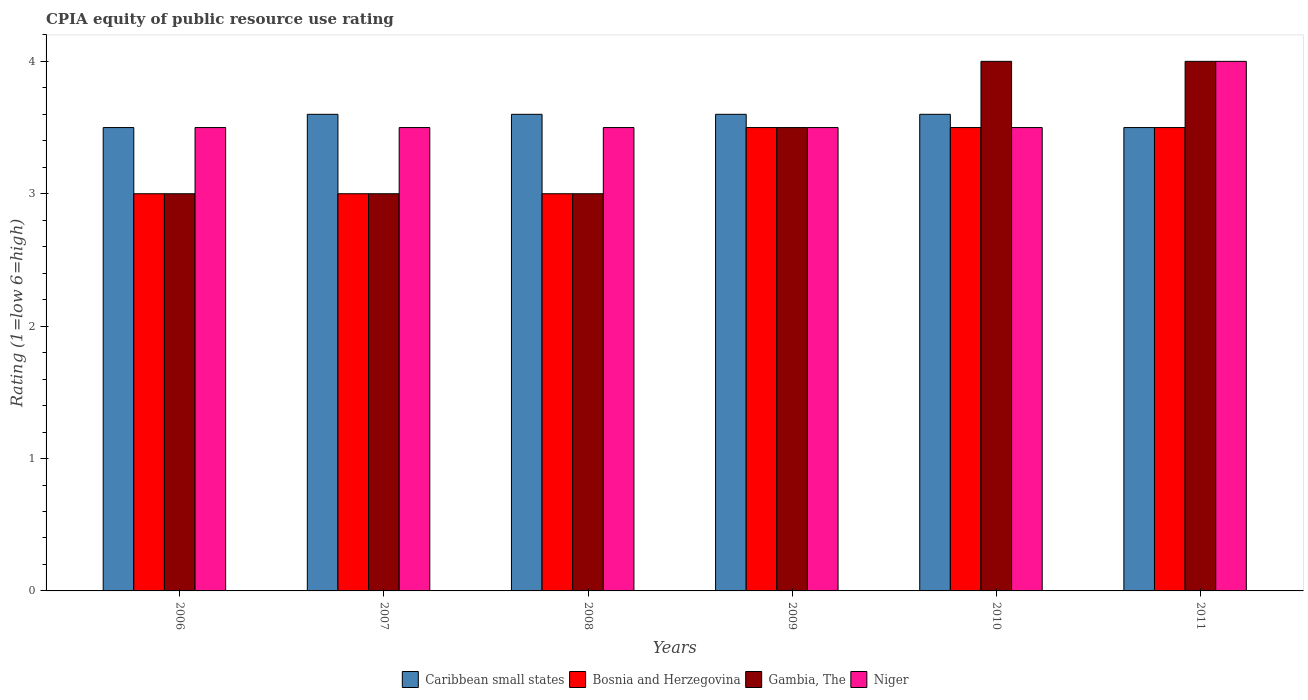How many groups of bars are there?
Provide a short and direct response. 6. How many bars are there on the 4th tick from the left?
Make the answer very short. 4. What is the label of the 3rd group of bars from the left?
Your response must be concise. 2008. In how many cases, is the number of bars for a given year not equal to the number of legend labels?
Give a very brief answer. 0. What is the CPIA rating in Gambia, The in 2009?
Offer a terse response. 3.5. In which year was the CPIA rating in Niger minimum?
Make the answer very short. 2006. What is the average CPIA rating in Bosnia and Herzegovina per year?
Keep it short and to the point. 3.25. In the year 2010, what is the difference between the CPIA rating in Niger and CPIA rating in Caribbean small states?
Offer a terse response. -0.1. What is the ratio of the CPIA rating in Caribbean small states in 2007 to that in 2011?
Keep it short and to the point. 1.03. What is the difference between the highest and the lowest CPIA rating in Gambia, The?
Make the answer very short. 1. Is the sum of the CPIA rating in Niger in 2009 and 2011 greater than the maximum CPIA rating in Bosnia and Herzegovina across all years?
Your response must be concise. Yes. Is it the case that in every year, the sum of the CPIA rating in Bosnia and Herzegovina and CPIA rating in Niger is greater than the sum of CPIA rating in Gambia, The and CPIA rating in Caribbean small states?
Your answer should be compact. No. What does the 4th bar from the left in 2006 represents?
Provide a succinct answer. Niger. What does the 4th bar from the right in 2011 represents?
Provide a short and direct response. Caribbean small states. How many bars are there?
Provide a succinct answer. 24. Are all the bars in the graph horizontal?
Your answer should be very brief. No. What is the difference between two consecutive major ticks on the Y-axis?
Provide a short and direct response. 1. Does the graph contain any zero values?
Give a very brief answer. No. Does the graph contain grids?
Provide a short and direct response. No. How many legend labels are there?
Your answer should be very brief. 4. How are the legend labels stacked?
Ensure brevity in your answer.  Horizontal. What is the title of the graph?
Your answer should be very brief. CPIA equity of public resource use rating. What is the label or title of the X-axis?
Provide a short and direct response. Years. What is the Rating (1=low 6=high) in Gambia, The in 2007?
Offer a very short reply. 3. What is the Rating (1=low 6=high) of Niger in 2007?
Offer a very short reply. 3.5. What is the Rating (1=low 6=high) in Gambia, The in 2008?
Give a very brief answer. 3. What is the Rating (1=low 6=high) of Niger in 2008?
Your response must be concise. 3.5. What is the Rating (1=low 6=high) of Gambia, The in 2009?
Your response must be concise. 3.5. What is the Rating (1=low 6=high) of Niger in 2009?
Your answer should be compact. 3.5. What is the Rating (1=low 6=high) of Caribbean small states in 2010?
Provide a short and direct response. 3.6. What is the Rating (1=low 6=high) in Gambia, The in 2011?
Give a very brief answer. 4. Across all years, what is the maximum Rating (1=low 6=high) of Bosnia and Herzegovina?
Offer a very short reply. 3.5. Across all years, what is the minimum Rating (1=low 6=high) in Caribbean small states?
Your answer should be very brief. 3.5. Across all years, what is the minimum Rating (1=low 6=high) in Gambia, The?
Your answer should be compact. 3. What is the total Rating (1=low 6=high) in Caribbean small states in the graph?
Offer a terse response. 21.4. What is the total Rating (1=low 6=high) in Bosnia and Herzegovina in the graph?
Offer a very short reply. 19.5. What is the difference between the Rating (1=low 6=high) in Caribbean small states in 2006 and that in 2007?
Give a very brief answer. -0.1. What is the difference between the Rating (1=low 6=high) in Bosnia and Herzegovina in 2006 and that in 2007?
Make the answer very short. 0. What is the difference between the Rating (1=low 6=high) in Gambia, The in 2006 and that in 2007?
Give a very brief answer. 0. What is the difference between the Rating (1=low 6=high) in Niger in 2006 and that in 2007?
Ensure brevity in your answer.  0. What is the difference between the Rating (1=low 6=high) in Caribbean small states in 2006 and that in 2008?
Provide a short and direct response. -0.1. What is the difference between the Rating (1=low 6=high) in Gambia, The in 2006 and that in 2008?
Offer a terse response. 0. What is the difference between the Rating (1=low 6=high) in Niger in 2006 and that in 2008?
Your answer should be very brief. 0. What is the difference between the Rating (1=low 6=high) of Caribbean small states in 2006 and that in 2009?
Provide a short and direct response. -0.1. What is the difference between the Rating (1=low 6=high) in Gambia, The in 2006 and that in 2009?
Ensure brevity in your answer.  -0.5. What is the difference between the Rating (1=low 6=high) of Bosnia and Herzegovina in 2006 and that in 2010?
Keep it short and to the point. -0.5. What is the difference between the Rating (1=low 6=high) of Niger in 2006 and that in 2010?
Make the answer very short. 0. What is the difference between the Rating (1=low 6=high) of Caribbean small states in 2006 and that in 2011?
Give a very brief answer. 0. What is the difference between the Rating (1=low 6=high) in Niger in 2006 and that in 2011?
Your answer should be very brief. -0.5. What is the difference between the Rating (1=low 6=high) of Caribbean small states in 2007 and that in 2008?
Your response must be concise. 0. What is the difference between the Rating (1=low 6=high) of Gambia, The in 2007 and that in 2008?
Your answer should be compact. 0. What is the difference between the Rating (1=low 6=high) of Caribbean small states in 2007 and that in 2009?
Make the answer very short. 0. What is the difference between the Rating (1=low 6=high) in Niger in 2007 and that in 2009?
Give a very brief answer. 0. What is the difference between the Rating (1=low 6=high) of Gambia, The in 2007 and that in 2010?
Give a very brief answer. -1. What is the difference between the Rating (1=low 6=high) in Gambia, The in 2007 and that in 2011?
Offer a terse response. -1. What is the difference between the Rating (1=low 6=high) in Niger in 2007 and that in 2011?
Your answer should be compact. -0.5. What is the difference between the Rating (1=low 6=high) of Bosnia and Herzegovina in 2008 and that in 2009?
Offer a very short reply. -0.5. What is the difference between the Rating (1=low 6=high) in Gambia, The in 2008 and that in 2009?
Your answer should be very brief. -0.5. What is the difference between the Rating (1=low 6=high) in Bosnia and Herzegovina in 2008 and that in 2010?
Offer a very short reply. -0.5. What is the difference between the Rating (1=low 6=high) of Gambia, The in 2008 and that in 2010?
Keep it short and to the point. -1. What is the difference between the Rating (1=low 6=high) in Niger in 2008 and that in 2010?
Make the answer very short. 0. What is the difference between the Rating (1=low 6=high) in Caribbean small states in 2008 and that in 2011?
Your answer should be very brief. 0.1. What is the difference between the Rating (1=low 6=high) in Bosnia and Herzegovina in 2008 and that in 2011?
Provide a short and direct response. -0.5. What is the difference between the Rating (1=low 6=high) in Niger in 2008 and that in 2011?
Provide a short and direct response. -0.5. What is the difference between the Rating (1=low 6=high) of Bosnia and Herzegovina in 2009 and that in 2010?
Give a very brief answer. 0. What is the difference between the Rating (1=low 6=high) of Gambia, The in 2009 and that in 2010?
Make the answer very short. -0.5. What is the difference between the Rating (1=low 6=high) of Niger in 2009 and that in 2010?
Offer a very short reply. 0. What is the difference between the Rating (1=low 6=high) of Bosnia and Herzegovina in 2009 and that in 2011?
Keep it short and to the point. 0. What is the difference between the Rating (1=low 6=high) in Gambia, The in 2010 and that in 2011?
Your response must be concise. 0. What is the difference between the Rating (1=low 6=high) of Niger in 2010 and that in 2011?
Give a very brief answer. -0.5. What is the difference between the Rating (1=low 6=high) of Caribbean small states in 2006 and the Rating (1=low 6=high) of Bosnia and Herzegovina in 2007?
Make the answer very short. 0.5. What is the difference between the Rating (1=low 6=high) in Caribbean small states in 2006 and the Rating (1=low 6=high) in Niger in 2007?
Your response must be concise. 0. What is the difference between the Rating (1=low 6=high) in Gambia, The in 2006 and the Rating (1=low 6=high) in Niger in 2007?
Your answer should be very brief. -0.5. What is the difference between the Rating (1=low 6=high) in Caribbean small states in 2006 and the Rating (1=low 6=high) in Gambia, The in 2008?
Provide a succinct answer. 0.5. What is the difference between the Rating (1=low 6=high) of Caribbean small states in 2006 and the Rating (1=low 6=high) of Niger in 2008?
Provide a succinct answer. 0. What is the difference between the Rating (1=low 6=high) of Bosnia and Herzegovina in 2006 and the Rating (1=low 6=high) of Gambia, The in 2008?
Provide a short and direct response. 0. What is the difference between the Rating (1=low 6=high) in Bosnia and Herzegovina in 2006 and the Rating (1=low 6=high) in Niger in 2008?
Keep it short and to the point. -0.5. What is the difference between the Rating (1=low 6=high) of Caribbean small states in 2006 and the Rating (1=low 6=high) of Bosnia and Herzegovina in 2009?
Offer a terse response. 0. What is the difference between the Rating (1=low 6=high) in Caribbean small states in 2006 and the Rating (1=low 6=high) in Gambia, The in 2009?
Your answer should be compact. 0. What is the difference between the Rating (1=low 6=high) of Bosnia and Herzegovina in 2006 and the Rating (1=low 6=high) of Gambia, The in 2009?
Ensure brevity in your answer.  -0.5. What is the difference between the Rating (1=low 6=high) in Caribbean small states in 2006 and the Rating (1=low 6=high) in Niger in 2010?
Provide a succinct answer. 0. What is the difference between the Rating (1=low 6=high) in Bosnia and Herzegovina in 2006 and the Rating (1=low 6=high) in Gambia, The in 2010?
Make the answer very short. -1. What is the difference between the Rating (1=low 6=high) in Caribbean small states in 2006 and the Rating (1=low 6=high) in Gambia, The in 2011?
Offer a terse response. -0.5. What is the difference between the Rating (1=low 6=high) of Bosnia and Herzegovina in 2006 and the Rating (1=low 6=high) of Gambia, The in 2011?
Make the answer very short. -1. What is the difference between the Rating (1=low 6=high) in Gambia, The in 2006 and the Rating (1=low 6=high) in Niger in 2011?
Keep it short and to the point. -1. What is the difference between the Rating (1=low 6=high) of Caribbean small states in 2007 and the Rating (1=low 6=high) of Gambia, The in 2008?
Ensure brevity in your answer.  0.6. What is the difference between the Rating (1=low 6=high) in Bosnia and Herzegovina in 2007 and the Rating (1=low 6=high) in Gambia, The in 2008?
Your response must be concise. 0. What is the difference between the Rating (1=low 6=high) of Bosnia and Herzegovina in 2007 and the Rating (1=low 6=high) of Niger in 2008?
Your answer should be compact. -0.5. What is the difference between the Rating (1=low 6=high) of Caribbean small states in 2007 and the Rating (1=low 6=high) of Bosnia and Herzegovina in 2009?
Your response must be concise. 0.1. What is the difference between the Rating (1=low 6=high) in Gambia, The in 2007 and the Rating (1=low 6=high) in Niger in 2009?
Offer a very short reply. -0.5. What is the difference between the Rating (1=low 6=high) in Caribbean small states in 2007 and the Rating (1=low 6=high) in Gambia, The in 2010?
Provide a short and direct response. -0.4. What is the difference between the Rating (1=low 6=high) of Caribbean small states in 2007 and the Rating (1=low 6=high) of Bosnia and Herzegovina in 2011?
Give a very brief answer. 0.1. What is the difference between the Rating (1=low 6=high) in Caribbean small states in 2007 and the Rating (1=low 6=high) in Gambia, The in 2011?
Provide a short and direct response. -0.4. What is the difference between the Rating (1=low 6=high) of Caribbean small states in 2007 and the Rating (1=low 6=high) of Niger in 2011?
Offer a very short reply. -0.4. What is the difference between the Rating (1=low 6=high) of Bosnia and Herzegovina in 2007 and the Rating (1=low 6=high) of Niger in 2011?
Your answer should be compact. -1. What is the difference between the Rating (1=low 6=high) in Gambia, The in 2007 and the Rating (1=low 6=high) in Niger in 2011?
Make the answer very short. -1. What is the difference between the Rating (1=low 6=high) of Caribbean small states in 2008 and the Rating (1=low 6=high) of Niger in 2009?
Offer a very short reply. 0.1. What is the difference between the Rating (1=low 6=high) of Bosnia and Herzegovina in 2008 and the Rating (1=low 6=high) of Gambia, The in 2009?
Keep it short and to the point. -0.5. What is the difference between the Rating (1=low 6=high) of Bosnia and Herzegovina in 2008 and the Rating (1=low 6=high) of Niger in 2009?
Your answer should be very brief. -0.5. What is the difference between the Rating (1=low 6=high) of Caribbean small states in 2008 and the Rating (1=low 6=high) of Gambia, The in 2010?
Your answer should be very brief. -0.4. What is the difference between the Rating (1=low 6=high) of Caribbean small states in 2008 and the Rating (1=low 6=high) of Niger in 2010?
Your answer should be very brief. 0.1. What is the difference between the Rating (1=low 6=high) in Bosnia and Herzegovina in 2008 and the Rating (1=low 6=high) in Niger in 2010?
Offer a terse response. -0.5. What is the difference between the Rating (1=low 6=high) in Gambia, The in 2008 and the Rating (1=low 6=high) in Niger in 2010?
Offer a very short reply. -0.5. What is the difference between the Rating (1=low 6=high) in Caribbean small states in 2008 and the Rating (1=low 6=high) in Bosnia and Herzegovina in 2011?
Provide a succinct answer. 0.1. What is the difference between the Rating (1=low 6=high) in Caribbean small states in 2008 and the Rating (1=low 6=high) in Gambia, The in 2011?
Provide a succinct answer. -0.4. What is the difference between the Rating (1=low 6=high) of Bosnia and Herzegovina in 2008 and the Rating (1=low 6=high) of Gambia, The in 2011?
Your response must be concise. -1. What is the difference between the Rating (1=low 6=high) of Gambia, The in 2008 and the Rating (1=low 6=high) of Niger in 2011?
Provide a short and direct response. -1. What is the difference between the Rating (1=low 6=high) in Caribbean small states in 2009 and the Rating (1=low 6=high) in Bosnia and Herzegovina in 2010?
Make the answer very short. 0.1. What is the difference between the Rating (1=low 6=high) in Bosnia and Herzegovina in 2009 and the Rating (1=low 6=high) in Gambia, The in 2010?
Provide a short and direct response. -0.5. What is the difference between the Rating (1=low 6=high) in Bosnia and Herzegovina in 2009 and the Rating (1=low 6=high) in Niger in 2010?
Make the answer very short. 0. What is the difference between the Rating (1=low 6=high) of Gambia, The in 2009 and the Rating (1=low 6=high) of Niger in 2010?
Make the answer very short. 0. What is the difference between the Rating (1=low 6=high) in Caribbean small states in 2009 and the Rating (1=low 6=high) in Bosnia and Herzegovina in 2011?
Ensure brevity in your answer.  0.1. What is the difference between the Rating (1=low 6=high) in Caribbean small states in 2009 and the Rating (1=low 6=high) in Gambia, The in 2011?
Ensure brevity in your answer.  -0.4. What is the difference between the Rating (1=low 6=high) of Bosnia and Herzegovina in 2009 and the Rating (1=low 6=high) of Gambia, The in 2011?
Your answer should be compact. -0.5. What is the difference between the Rating (1=low 6=high) of Bosnia and Herzegovina in 2009 and the Rating (1=low 6=high) of Niger in 2011?
Your response must be concise. -0.5. What is the difference between the Rating (1=low 6=high) of Caribbean small states in 2010 and the Rating (1=low 6=high) of Gambia, The in 2011?
Provide a succinct answer. -0.4. What is the difference between the Rating (1=low 6=high) of Bosnia and Herzegovina in 2010 and the Rating (1=low 6=high) of Niger in 2011?
Your response must be concise. -0.5. What is the average Rating (1=low 6=high) of Caribbean small states per year?
Provide a short and direct response. 3.57. What is the average Rating (1=low 6=high) of Gambia, The per year?
Your response must be concise. 3.42. What is the average Rating (1=low 6=high) of Niger per year?
Offer a terse response. 3.58. In the year 2006, what is the difference between the Rating (1=low 6=high) in Caribbean small states and Rating (1=low 6=high) in Gambia, The?
Provide a succinct answer. 0.5. In the year 2006, what is the difference between the Rating (1=low 6=high) in Caribbean small states and Rating (1=low 6=high) in Niger?
Provide a succinct answer. 0. In the year 2006, what is the difference between the Rating (1=low 6=high) in Bosnia and Herzegovina and Rating (1=low 6=high) in Gambia, The?
Make the answer very short. 0. In the year 2006, what is the difference between the Rating (1=low 6=high) of Bosnia and Herzegovina and Rating (1=low 6=high) of Niger?
Offer a very short reply. -0.5. In the year 2006, what is the difference between the Rating (1=low 6=high) of Gambia, The and Rating (1=low 6=high) of Niger?
Your response must be concise. -0.5. In the year 2007, what is the difference between the Rating (1=low 6=high) of Bosnia and Herzegovina and Rating (1=low 6=high) of Gambia, The?
Your response must be concise. 0. In the year 2007, what is the difference between the Rating (1=low 6=high) of Bosnia and Herzegovina and Rating (1=low 6=high) of Niger?
Give a very brief answer. -0.5. In the year 2007, what is the difference between the Rating (1=low 6=high) of Gambia, The and Rating (1=low 6=high) of Niger?
Your response must be concise. -0.5. In the year 2008, what is the difference between the Rating (1=low 6=high) of Caribbean small states and Rating (1=low 6=high) of Niger?
Your response must be concise. 0.1. In the year 2009, what is the difference between the Rating (1=low 6=high) in Caribbean small states and Rating (1=low 6=high) in Bosnia and Herzegovina?
Provide a short and direct response. 0.1. In the year 2009, what is the difference between the Rating (1=low 6=high) in Caribbean small states and Rating (1=low 6=high) in Niger?
Keep it short and to the point. 0.1. In the year 2009, what is the difference between the Rating (1=low 6=high) in Bosnia and Herzegovina and Rating (1=low 6=high) in Gambia, The?
Offer a very short reply. 0. In the year 2010, what is the difference between the Rating (1=low 6=high) of Caribbean small states and Rating (1=low 6=high) of Niger?
Offer a terse response. 0.1. In the year 2010, what is the difference between the Rating (1=low 6=high) in Bosnia and Herzegovina and Rating (1=low 6=high) in Gambia, The?
Offer a terse response. -0.5. In the year 2010, what is the difference between the Rating (1=low 6=high) in Gambia, The and Rating (1=low 6=high) in Niger?
Keep it short and to the point. 0.5. In the year 2011, what is the difference between the Rating (1=low 6=high) in Bosnia and Herzegovina and Rating (1=low 6=high) in Gambia, The?
Provide a short and direct response. -0.5. In the year 2011, what is the difference between the Rating (1=low 6=high) of Bosnia and Herzegovina and Rating (1=low 6=high) of Niger?
Keep it short and to the point. -0.5. In the year 2011, what is the difference between the Rating (1=low 6=high) of Gambia, The and Rating (1=low 6=high) of Niger?
Ensure brevity in your answer.  0. What is the ratio of the Rating (1=low 6=high) of Caribbean small states in 2006 to that in 2007?
Keep it short and to the point. 0.97. What is the ratio of the Rating (1=low 6=high) of Bosnia and Herzegovina in 2006 to that in 2007?
Provide a short and direct response. 1. What is the ratio of the Rating (1=low 6=high) in Gambia, The in 2006 to that in 2007?
Offer a very short reply. 1. What is the ratio of the Rating (1=low 6=high) of Caribbean small states in 2006 to that in 2008?
Your answer should be compact. 0.97. What is the ratio of the Rating (1=low 6=high) in Gambia, The in 2006 to that in 2008?
Give a very brief answer. 1. What is the ratio of the Rating (1=low 6=high) of Niger in 2006 to that in 2008?
Provide a short and direct response. 1. What is the ratio of the Rating (1=low 6=high) in Caribbean small states in 2006 to that in 2009?
Offer a terse response. 0.97. What is the ratio of the Rating (1=low 6=high) in Gambia, The in 2006 to that in 2009?
Provide a short and direct response. 0.86. What is the ratio of the Rating (1=low 6=high) in Niger in 2006 to that in 2009?
Provide a short and direct response. 1. What is the ratio of the Rating (1=low 6=high) of Caribbean small states in 2006 to that in 2010?
Provide a short and direct response. 0.97. What is the ratio of the Rating (1=low 6=high) of Bosnia and Herzegovina in 2006 to that in 2010?
Provide a succinct answer. 0.86. What is the ratio of the Rating (1=low 6=high) in Gambia, The in 2006 to that in 2010?
Give a very brief answer. 0.75. What is the ratio of the Rating (1=low 6=high) of Niger in 2006 to that in 2010?
Keep it short and to the point. 1. What is the ratio of the Rating (1=low 6=high) of Bosnia and Herzegovina in 2006 to that in 2011?
Provide a succinct answer. 0.86. What is the ratio of the Rating (1=low 6=high) of Caribbean small states in 2007 to that in 2008?
Your answer should be very brief. 1. What is the ratio of the Rating (1=low 6=high) of Bosnia and Herzegovina in 2007 to that in 2008?
Give a very brief answer. 1. What is the ratio of the Rating (1=low 6=high) in Gambia, The in 2007 to that in 2008?
Offer a very short reply. 1. What is the ratio of the Rating (1=low 6=high) in Gambia, The in 2007 to that in 2009?
Ensure brevity in your answer.  0.86. What is the ratio of the Rating (1=low 6=high) of Niger in 2007 to that in 2009?
Ensure brevity in your answer.  1. What is the ratio of the Rating (1=low 6=high) in Bosnia and Herzegovina in 2007 to that in 2010?
Your answer should be compact. 0.86. What is the ratio of the Rating (1=low 6=high) in Niger in 2007 to that in 2010?
Provide a short and direct response. 1. What is the ratio of the Rating (1=low 6=high) of Caribbean small states in 2007 to that in 2011?
Offer a terse response. 1.03. What is the ratio of the Rating (1=low 6=high) in Gambia, The in 2007 to that in 2011?
Offer a very short reply. 0.75. What is the ratio of the Rating (1=low 6=high) of Caribbean small states in 2008 to that in 2009?
Make the answer very short. 1. What is the ratio of the Rating (1=low 6=high) in Gambia, The in 2008 to that in 2009?
Keep it short and to the point. 0.86. What is the ratio of the Rating (1=low 6=high) in Niger in 2008 to that in 2009?
Your answer should be very brief. 1. What is the ratio of the Rating (1=low 6=high) in Gambia, The in 2008 to that in 2010?
Keep it short and to the point. 0.75. What is the ratio of the Rating (1=low 6=high) of Caribbean small states in 2008 to that in 2011?
Ensure brevity in your answer.  1.03. What is the ratio of the Rating (1=low 6=high) of Gambia, The in 2008 to that in 2011?
Give a very brief answer. 0.75. What is the ratio of the Rating (1=low 6=high) in Caribbean small states in 2009 to that in 2010?
Ensure brevity in your answer.  1. What is the ratio of the Rating (1=low 6=high) in Gambia, The in 2009 to that in 2010?
Make the answer very short. 0.88. What is the ratio of the Rating (1=low 6=high) of Niger in 2009 to that in 2010?
Offer a very short reply. 1. What is the ratio of the Rating (1=low 6=high) in Caribbean small states in 2009 to that in 2011?
Provide a short and direct response. 1.03. What is the ratio of the Rating (1=low 6=high) in Bosnia and Herzegovina in 2009 to that in 2011?
Provide a succinct answer. 1. What is the ratio of the Rating (1=low 6=high) in Gambia, The in 2009 to that in 2011?
Your response must be concise. 0.88. What is the ratio of the Rating (1=low 6=high) of Caribbean small states in 2010 to that in 2011?
Your answer should be compact. 1.03. What is the ratio of the Rating (1=low 6=high) in Bosnia and Herzegovina in 2010 to that in 2011?
Ensure brevity in your answer.  1. What is the ratio of the Rating (1=low 6=high) in Niger in 2010 to that in 2011?
Your response must be concise. 0.88. What is the difference between the highest and the second highest Rating (1=low 6=high) in Caribbean small states?
Offer a terse response. 0. What is the difference between the highest and the second highest Rating (1=low 6=high) of Bosnia and Herzegovina?
Provide a short and direct response. 0. What is the difference between the highest and the second highest Rating (1=low 6=high) in Gambia, The?
Your response must be concise. 0. What is the difference between the highest and the second highest Rating (1=low 6=high) in Niger?
Provide a succinct answer. 0.5. What is the difference between the highest and the lowest Rating (1=low 6=high) in Gambia, The?
Make the answer very short. 1. 